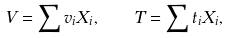<formula> <loc_0><loc_0><loc_500><loc_500>V = \sum v _ { i } X _ { i } , \quad T = \sum t _ { i } X _ { i } ,</formula> 